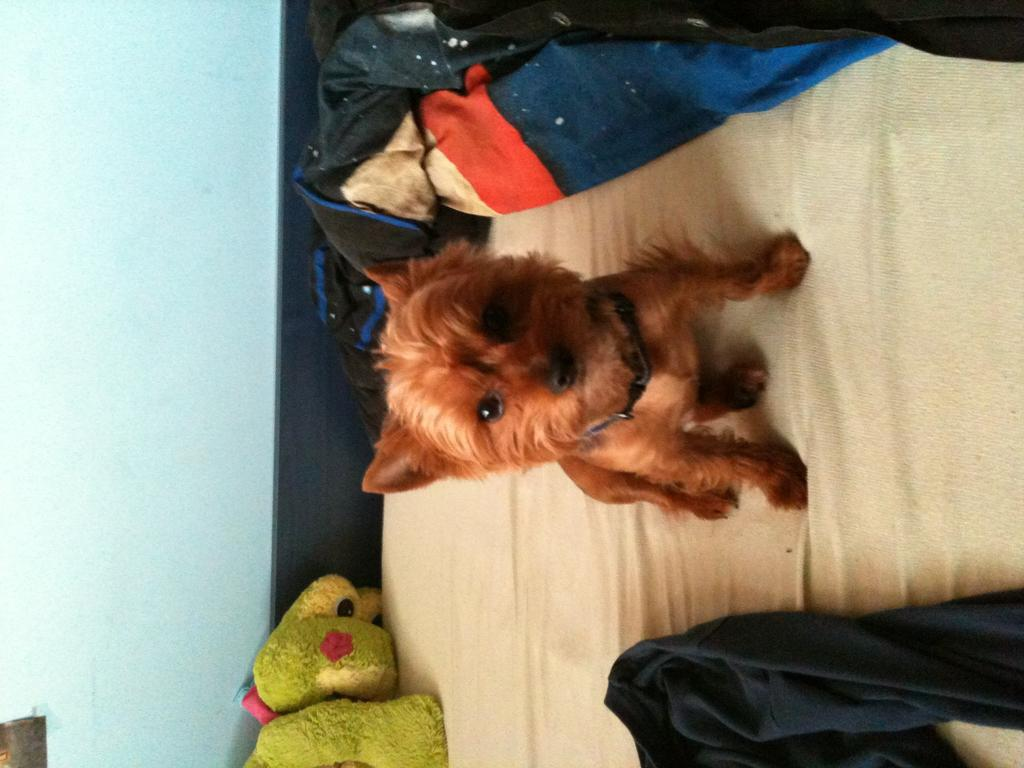In which direction is the image oriented? The image is in the left direction. What type of animal is present in the image? There is a dog in the image. What else can be seen in the image besides the dog? There are toys and clothes placed on a bed in the image. What is the dog looking at in the image? The dog is looking at a picture. What is on the left side of the image? There is a wall on the left side of the image. Can you tell me how many basketballs are visible in the image? There are no basketballs present in the image. Is there a kitty playing with the dog in the image? There is no kitty present in the image. 